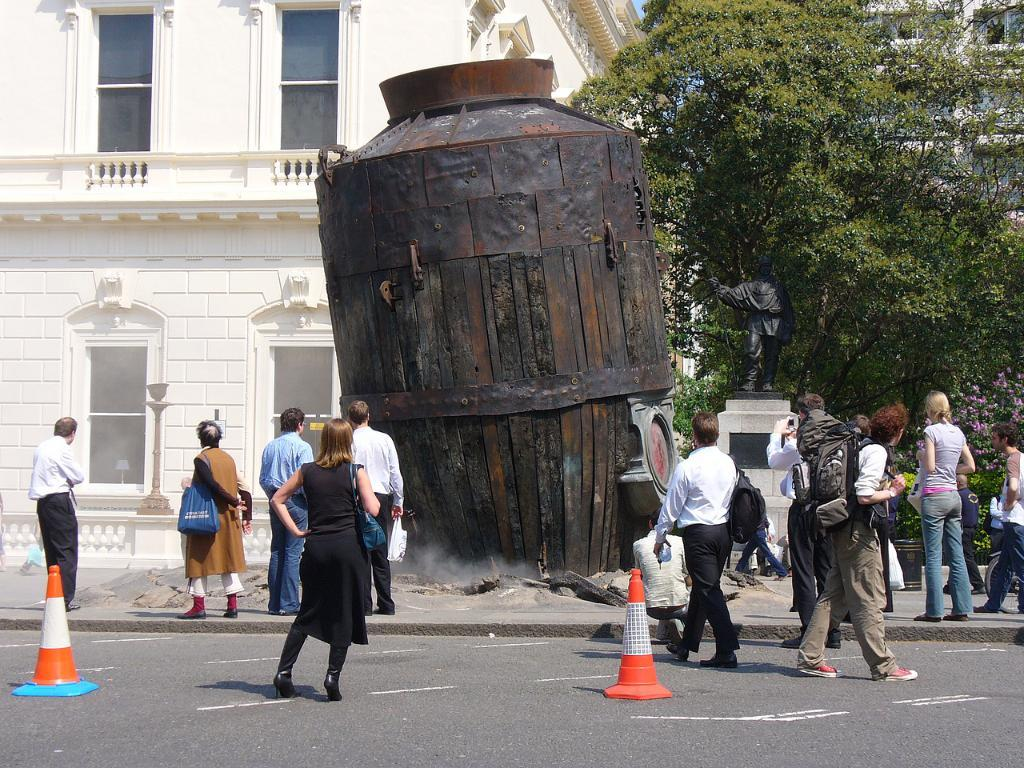How many people are in the group visible in the image? There is a group of people in the image, but the exact number cannot be determined from the provided facts. What can be seen on the ground in the image? Traffic cones are present on the ground in the image. What is the object in the image? There is an object in the image, but its description is not provided in the facts. What is on a platform in the image? A statue is on a platform in the image. What is visible in the background of the image? Buildings and trees are visible in the background of the image. What type of silk is draped over the statue in the image? There is no silk present in the image; the statue is on a platform without any fabric draped over it. 